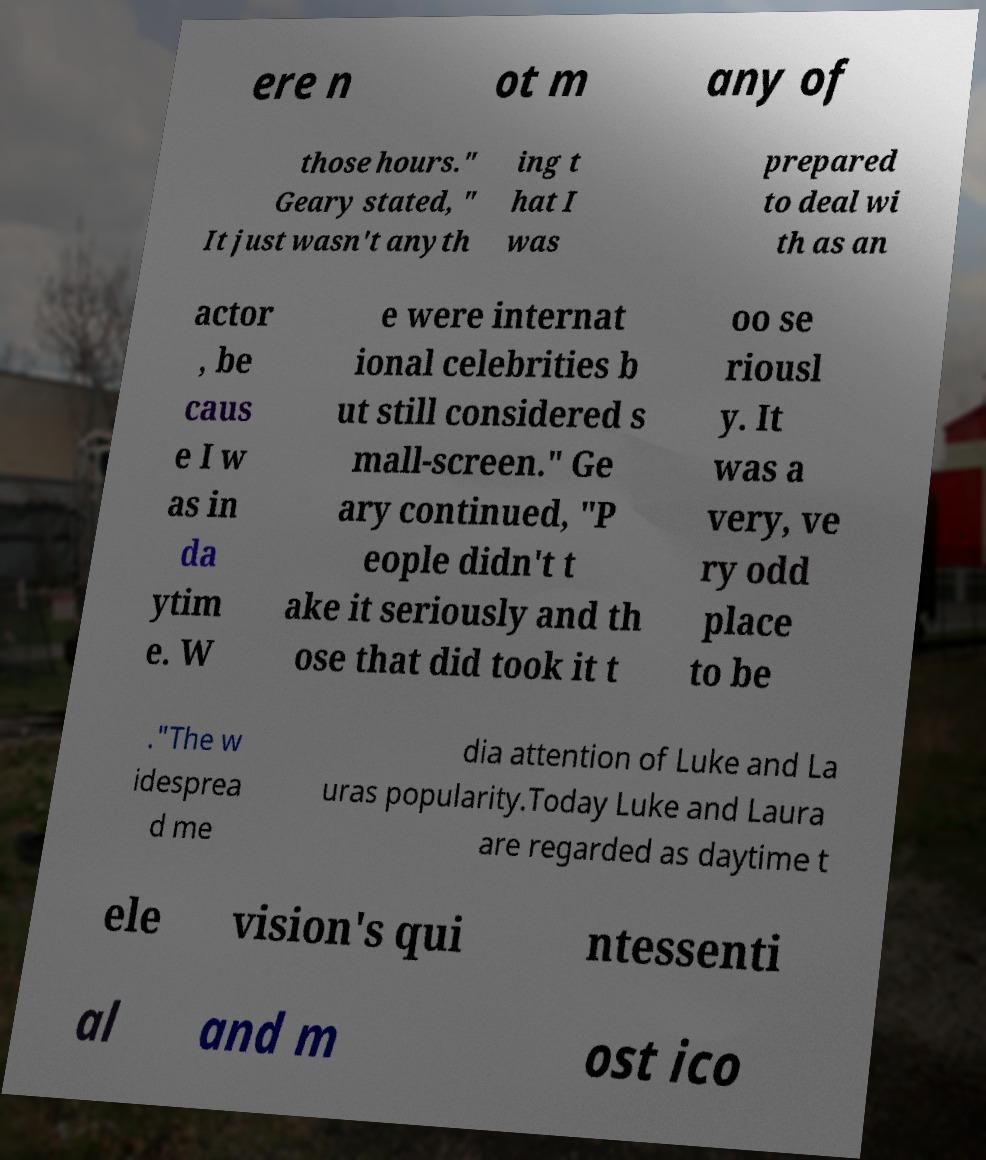Could you assist in decoding the text presented in this image and type it out clearly? ere n ot m any of those hours." Geary stated, " It just wasn't anyth ing t hat I was prepared to deal wi th as an actor , be caus e I w as in da ytim e. W e were internat ional celebrities b ut still considered s mall-screen." Ge ary continued, "P eople didn't t ake it seriously and th ose that did took it t oo se riousl y. It was a very, ve ry odd place to be ."The w idesprea d me dia attention of Luke and La uras popularity.Today Luke and Laura are regarded as daytime t ele vision's qui ntessenti al and m ost ico 